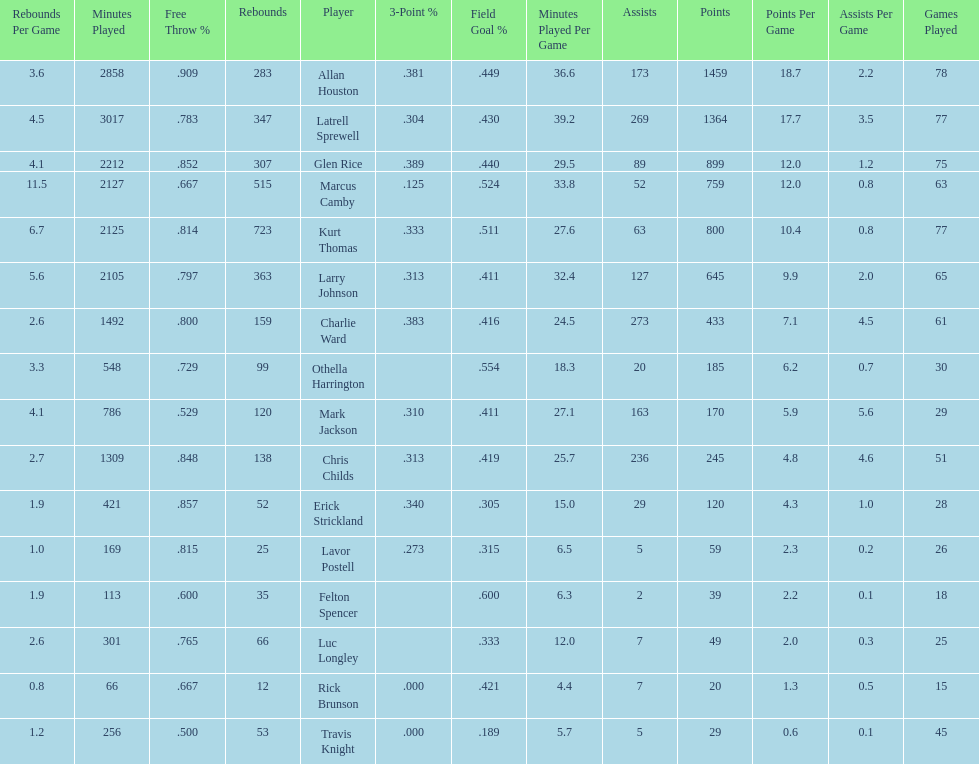How many more games did allan houston play than mark jackson? 49. Parse the table in full. {'header': ['Rebounds Per Game', 'Minutes Played', 'Free Throw\xa0%', 'Rebounds', 'Player', '3-Point\xa0%', 'Field Goal\xa0%', 'Minutes Played Per Game', 'Assists', 'Points', 'Points Per Game', 'Assists Per Game', 'Games Played'], 'rows': [['3.6', '2858', '.909', '283', 'Allan Houston', '.381', '.449', '36.6', '173', '1459', '18.7', '2.2', '78'], ['4.5', '3017', '.783', '347', 'Latrell Sprewell', '.304', '.430', '39.2', '269', '1364', '17.7', '3.5', '77'], ['4.1', '2212', '.852', '307', 'Glen Rice', '.389', '.440', '29.5', '89', '899', '12.0', '1.2', '75'], ['11.5', '2127', '.667', '515', 'Marcus Camby', '.125', '.524', '33.8', '52', '759', '12.0', '0.8', '63'], ['6.7', '2125', '.814', '723', 'Kurt Thomas', '.333', '.511', '27.6', '63', '800', '10.4', '0.8', '77'], ['5.6', '2105', '.797', '363', 'Larry Johnson', '.313', '.411', '32.4', '127', '645', '9.9', '2.0', '65'], ['2.6', '1492', '.800', '159', 'Charlie Ward', '.383', '.416', '24.5', '273', '433', '7.1', '4.5', '61'], ['3.3', '548', '.729', '99', 'Othella Harrington', '', '.554', '18.3', '20', '185', '6.2', '0.7', '30'], ['4.1', '786', '.529', '120', 'Mark Jackson', '.310', '.411', '27.1', '163', '170', '5.9', '5.6', '29'], ['2.7', '1309', '.848', '138', 'Chris Childs', '.313', '.419', '25.7', '236', '245', '4.8', '4.6', '51'], ['1.9', '421', '.857', '52', 'Erick Strickland', '.340', '.305', '15.0', '29', '120', '4.3', '1.0', '28'], ['1.0', '169', '.815', '25', 'Lavor Postell', '.273', '.315', '6.5', '5', '59', '2.3', '0.2', '26'], ['1.9', '113', '.600', '35', 'Felton Spencer', '', '.600', '6.3', '2', '39', '2.2', '0.1', '18'], ['2.6', '301', '.765', '66', 'Luc Longley', '', '.333', '12.0', '7', '49', '2.0', '0.3', '25'], ['0.8', '66', '.667', '12', 'Rick Brunson', '.000', '.421', '4.4', '7', '20', '1.3', '0.5', '15'], ['1.2', '256', '.500', '53', 'Travis Knight', '.000', '.189', '5.7', '5', '29', '0.6', '0.1', '45']]} 